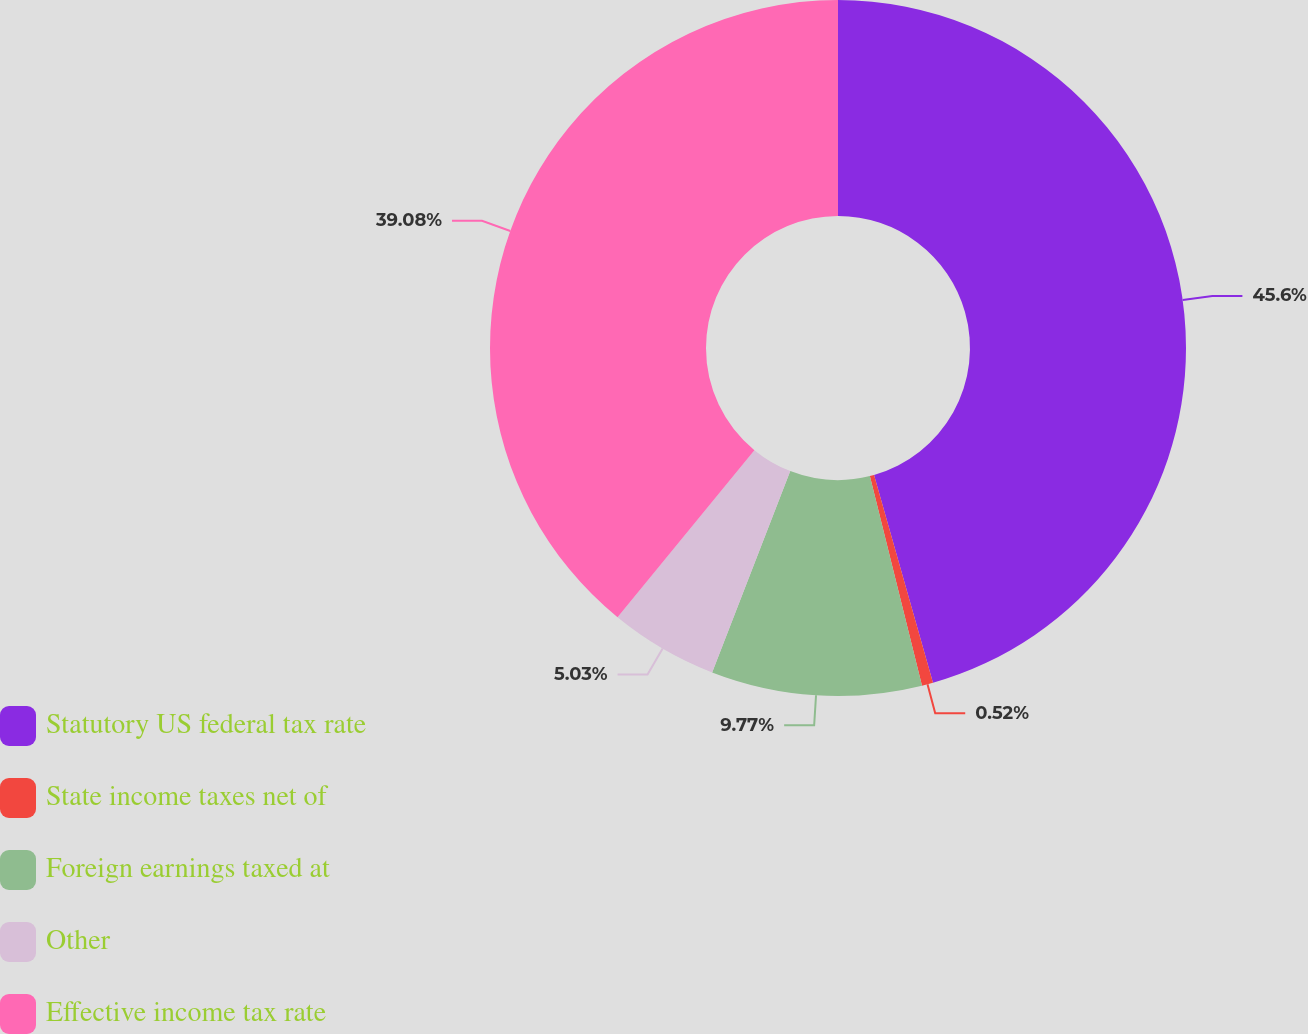Convert chart. <chart><loc_0><loc_0><loc_500><loc_500><pie_chart><fcel>Statutory US federal tax rate<fcel>State income taxes net of<fcel>Foreign earnings taxed at<fcel>Other<fcel>Effective income tax rate<nl><fcel>45.6%<fcel>0.52%<fcel>9.77%<fcel>5.03%<fcel>39.08%<nl></chart> 